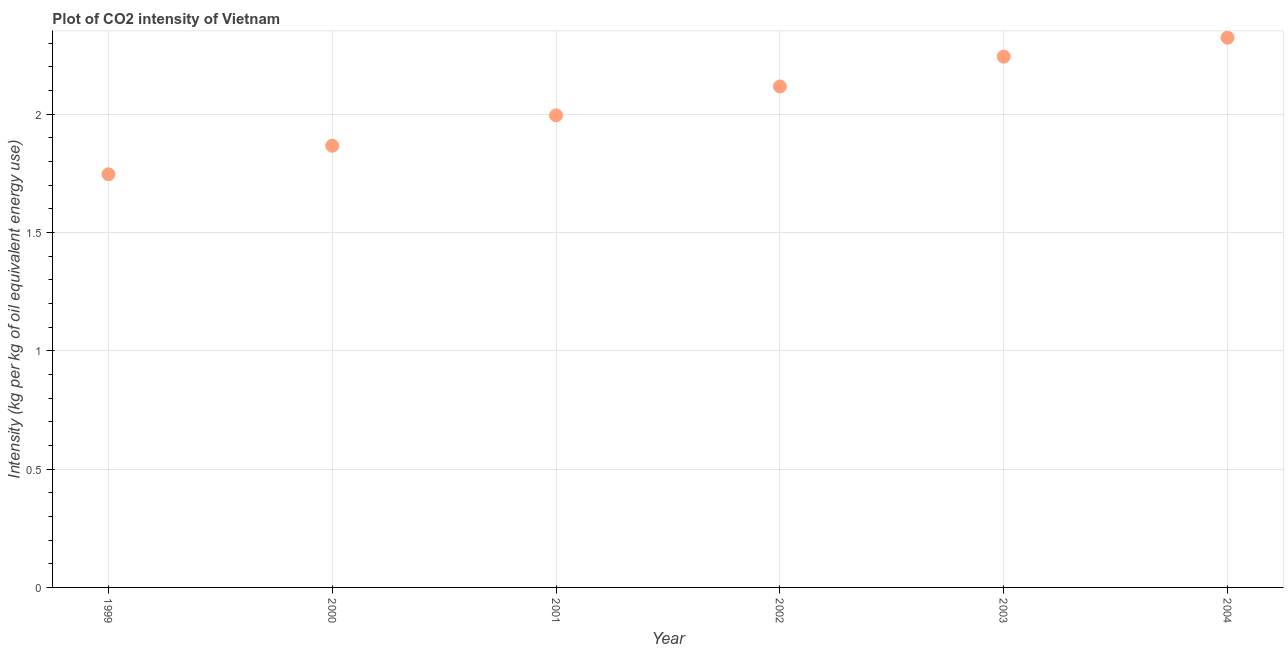What is the co2 intensity in 2001?
Provide a succinct answer. 2. Across all years, what is the maximum co2 intensity?
Keep it short and to the point. 2.32. Across all years, what is the minimum co2 intensity?
Keep it short and to the point. 1.75. In which year was the co2 intensity maximum?
Provide a succinct answer. 2004. In which year was the co2 intensity minimum?
Make the answer very short. 1999. What is the sum of the co2 intensity?
Provide a short and direct response. 12.29. What is the difference between the co2 intensity in 2001 and 2003?
Provide a short and direct response. -0.25. What is the average co2 intensity per year?
Keep it short and to the point. 2.05. What is the median co2 intensity?
Offer a terse response. 2.06. What is the ratio of the co2 intensity in 2001 to that in 2003?
Provide a short and direct response. 0.89. What is the difference between the highest and the second highest co2 intensity?
Your answer should be very brief. 0.08. Is the sum of the co2 intensity in 1999 and 2004 greater than the maximum co2 intensity across all years?
Give a very brief answer. Yes. What is the difference between the highest and the lowest co2 intensity?
Your answer should be very brief. 0.58. Does the co2 intensity monotonically increase over the years?
Your answer should be very brief. Yes. How many dotlines are there?
Your answer should be very brief. 1. Are the values on the major ticks of Y-axis written in scientific E-notation?
Your response must be concise. No. Does the graph contain any zero values?
Give a very brief answer. No. What is the title of the graph?
Provide a succinct answer. Plot of CO2 intensity of Vietnam. What is the label or title of the X-axis?
Keep it short and to the point. Year. What is the label or title of the Y-axis?
Your answer should be very brief. Intensity (kg per kg of oil equivalent energy use). What is the Intensity (kg per kg of oil equivalent energy use) in 1999?
Give a very brief answer. 1.75. What is the Intensity (kg per kg of oil equivalent energy use) in 2000?
Offer a terse response. 1.87. What is the Intensity (kg per kg of oil equivalent energy use) in 2001?
Keep it short and to the point. 2. What is the Intensity (kg per kg of oil equivalent energy use) in 2002?
Ensure brevity in your answer.  2.12. What is the Intensity (kg per kg of oil equivalent energy use) in 2003?
Keep it short and to the point. 2.24. What is the Intensity (kg per kg of oil equivalent energy use) in 2004?
Keep it short and to the point. 2.32. What is the difference between the Intensity (kg per kg of oil equivalent energy use) in 1999 and 2000?
Your answer should be compact. -0.12. What is the difference between the Intensity (kg per kg of oil equivalent energy use) in 1999 and 2001?
Offer a very short reply. -0.25. What is the difference between the Intensity (kg per kg of oil equivalent energy use) in 1999 and 2002?
Offer a very short reply. -0.37. What is the difference between the Intensity (kg per kg of oil equivalent energy use) in 1999 and 2003?
Make the answer very short. -0.5. What is the difference between the Intensity (kg per kg of oil equivalent energy use) in 1999 and 2004?
Your answer should be compact. -0.58. What is the difference between the Intensity (kg per kg of oil equivalent energy use) in 2000 and 2001?
Provide a succinct answer. -0.13. What is the difference between the Intensity (kg per kg of oil equivalent energy use) in 2000 and 2002?
Your response must be concise. -0.25. What is the difference between the Intensity (kg per kg of oil equivalent energy use) in 2000 and 2003?
Your response must be concise. -0.38. What is the difference between the Intensity (kg per kg of oil equivalent energy use) in 2000 and 2004?
Keep it short and to the point. -0.46. What is the difference between the Intensity (kg per kg of oil equivalent energy use) in 2001 and 2002?
Keep it short and to the point. -0.12. What is the difference between the Intensity (kg per kg of oil equivalent energy use) in 2001 and 2003?
Your response must be concise. -0.25. What is the difference between the Intensity (kg per kg of oil equivalent energy use) in 2001 and 2004?
Give a very brief answer. -0.33. What is the difference between the Intensity (kg per kg of oil equivalent energy use) in 2002 and 2003?
Offer a terse response. -0.13. What is the difference between the Intensity (kg per kg of oil equivalent energy use) in 2002 and 2004?
Your response must be concise. -0.21. What is the difference between the Intensity (kg per kg of oil equivalent energy use) in 2003 and 2004?
Your answer should be very brief. -0.08. What is the ratio of the Intensity (kg per kg of oil equivalent energy use) in 1999 to that in 2000?
Keep it short and to the point. 0.94. What is the ratio of the Intensity (kg per kg of oil equivalent energy use) in 1999 to that in 2001?
Keep it short and to the point. 0.88. What is the ratio of the Intensity (kg per kg of oil equivalent energy use) in 1999 to that in 2002?
Your answer should be compact. 0.82. What is the ratio of the Intensity (kg per kg of oil equivalent energy use) in 1999 to that in 2003?
Your answer should be very brief. 0.78. What is the ratio of the Intensity (kg per kg of oil equivalent energy use) in 1999 to that in 2004?
Offer a terse response. 0.75. What is the ratio of the Intensity (kg per kg of oil equivalent energy use) in 2000 to that in 2001?
Provide a succinct answer. 0.94. What is the ratio of the Intensity (kg per kg of oil equivalent energy use) in 2000 to that in 2002?
Keep it short and to the point. 0.88. What is the ratio of the Intensity (kg per kg of oil equivalent energy use) in 2000 to that in 2003?
Your response must be concise. 0.83. What is the ratio of the Intensity (kg per kg of oil equivalent energy use) in 2000 to that in 2004?
Ensure brevity in your answer.  0.8. What is the ratio of the Intensity (kg per kg of oil equivalent energy use) in 2001 to that in 2002?
Make the answer very short. 0.94. What is the ratio of the Intensity (kg per kg of oil equivalent energy use) in 2001 to that in 2003?
Provide a succinct answer. 0.89. What is the ratio of the Intensity (kg per kg of oil equivalent energy use) in 2001 to that in 2004?
Your answer should be compact. 0.86. What is the ratio of the Intensity (kg per kg of oil equivalent energy use) in 2002 to that in 2003?
Give a very brief answer. 0.94. What is the ratio of the Intensity (kg per kg of oil equivalent energy use) in 2002 to that in 2004?
Your answer should be compact. 0.91. 